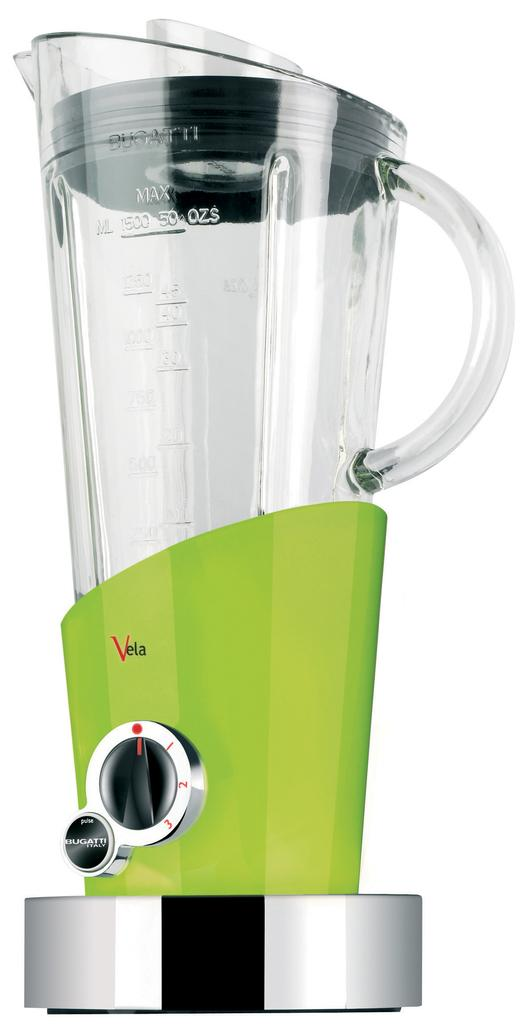<image>
Write a terse but informative summary of the picture. A blender by the brand name of "Vela" is visible. 